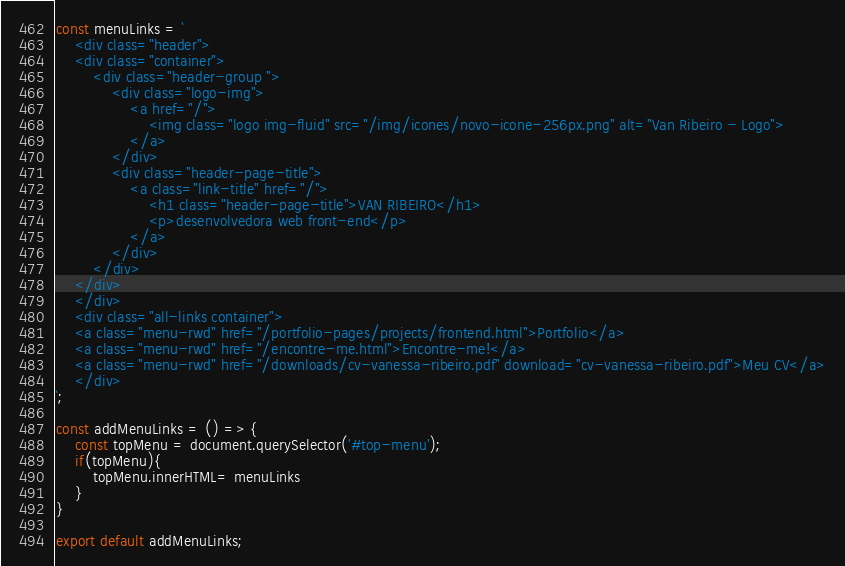Convert code to text. <code><loc_0><loc_0><loc_500><loc_500><_JavaScript_>const menuLinks = ` 
    <div class="header">
    <div class="container">
        <div class="header-group ">
            <div class="logo-img">
                <a href="/">
                    <img class="logo img-fluid" src="/img/icones/novo-icone-256px.png" alt="Van Ribeiro - Logo">
                </a>
            </div>
            <div class="header-page-title">
                <a class="link-title" href="/">
                    <h1 class="header-page-title">VAN RIBEIRO</h1>
                    <p>desenvolvedora web front-end</p>
                </a>
            </div>
        </div>
    </div>
    </div>
    <div class="all-links container">
    <a class="menu-rwd" href="/portfolio-pages/projects/frontend.html">Portfolio</a>
    <a class="menu-rwd" href="/encontre-me.html">Encontre-me!</a>
    <a class="menu-rwd" href="/downloads/cv-vanessa-ribeiro.pdf" download="cv-vanessa-ribeiro.pdf">Meu CV</a>
    </div>          
`;

const addMenuLinks = () => {
    const topMenu = document.querySelector('#top-menu');
    if(topMenu){
        topMenu.innerHTML= menuLinks
    }
}

export default addMenuLinks;</code> 